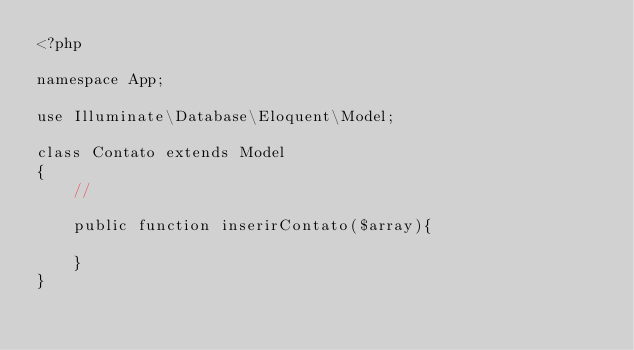Convert code to text. <code><loc_0><loc_0><loc_500><loc_500><_PHP_><?php

namespace App;

use Illuminate\Database\Eloquent\Model;

class Contato extends Model
{
    //

    public function inserirContato($array){
        
    }
}
</code> 